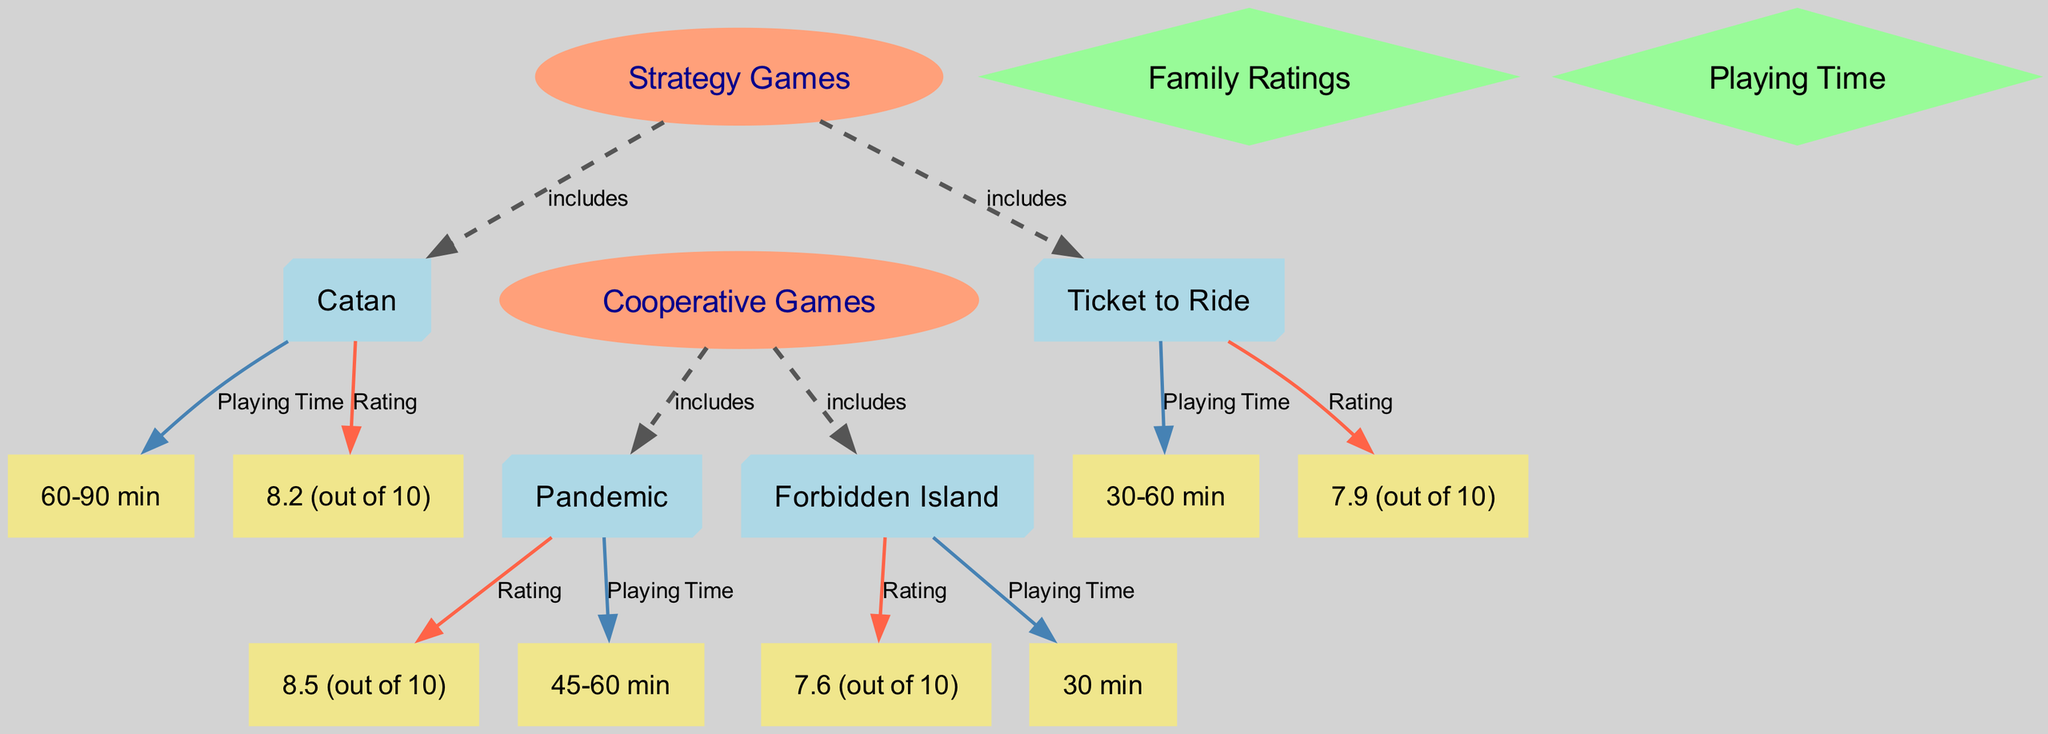What are the family ratings of Catan? The diagram shows that Catan's family rating is represented as "8.2 (out of 10)." This information is directly linked to the Catan node via the Rating edge.
Answer: 8.2 (out of 10) What is the playing time for Forbidden Island? The diagram provides that the playing time for Forbidden Island is indicated as "30 min." This data comes from the Forbidden Island node linked to the Playing Time node.
Answer: 30 min How many strategy games are listed in the diagram? There are two strategy games displayed in the diagram: Catan and Ticket to Ride. This can be determined by counting the number of nodes under the Strategy Games node.
Answer: 2 Which cooperative game has the highest family rating? The diagram reveals that Pandemic has a family rating of "8.5 (out of 10)," which is higher than Forbidden Island's rating of "7.6 (out of 10)." This comparison is necessary to answer the question clearly.
Answer: Pandemic What is the playing time range for Ticket to Ride? Ticket to Ride's playing time is shown as "30-60 min." This information is linked directly from the Ticket to Ride node to the Playing Time node in the diagram.
Answer: 30-60 min Which game has a higher family rating, Catan or Ticket to Ride? The diagram indicates that Catan has a family rating of "8.2 (out of 10)" while Ticket to Ride has "7.9 (out of 10)." By comparing these two ratings, it is clear Catan has a higher rating.
Answer: Catan What type of games does the strategy games category include? The strategy games category includes both Catan and Ticket to Ride as per the edges labeled "includes" from the Strategy Games node to each of these game nodes.
Answer: Catan, Ticket to Ride What is the total number of games listed in both categories? The diagram lists four games in total: Catan, Ticket to Ride, Pandemic, and Forbidden Island. This total includes both the Strategy Games and Cooperative Games categories.
Answer: 4 